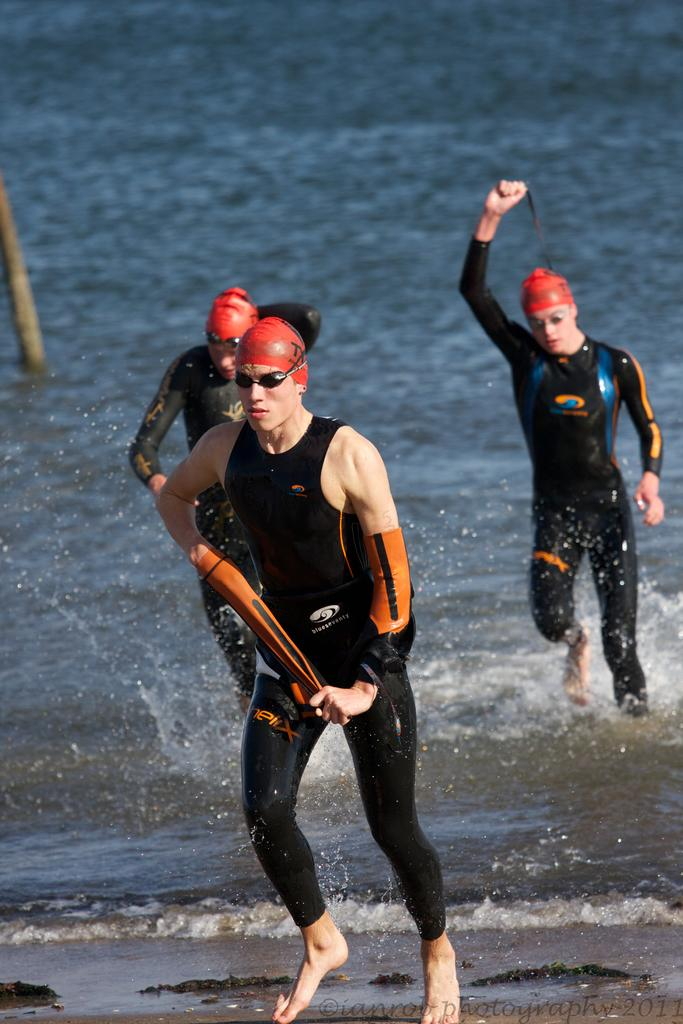How many people are in the image? There are three members in the image. What do all the members in the image have in common? All three members are wearing spectacles. What can be seen in the background of the image? There is an ocean visible in the background of the image. What type of rifle is being used by the members in the image? There is no rifle present in the image; the members are wearing spectacles and standing in front of an ocean. How does the iron affect the members in the image? There is no iron present in the image, so it cannot affect the members. 